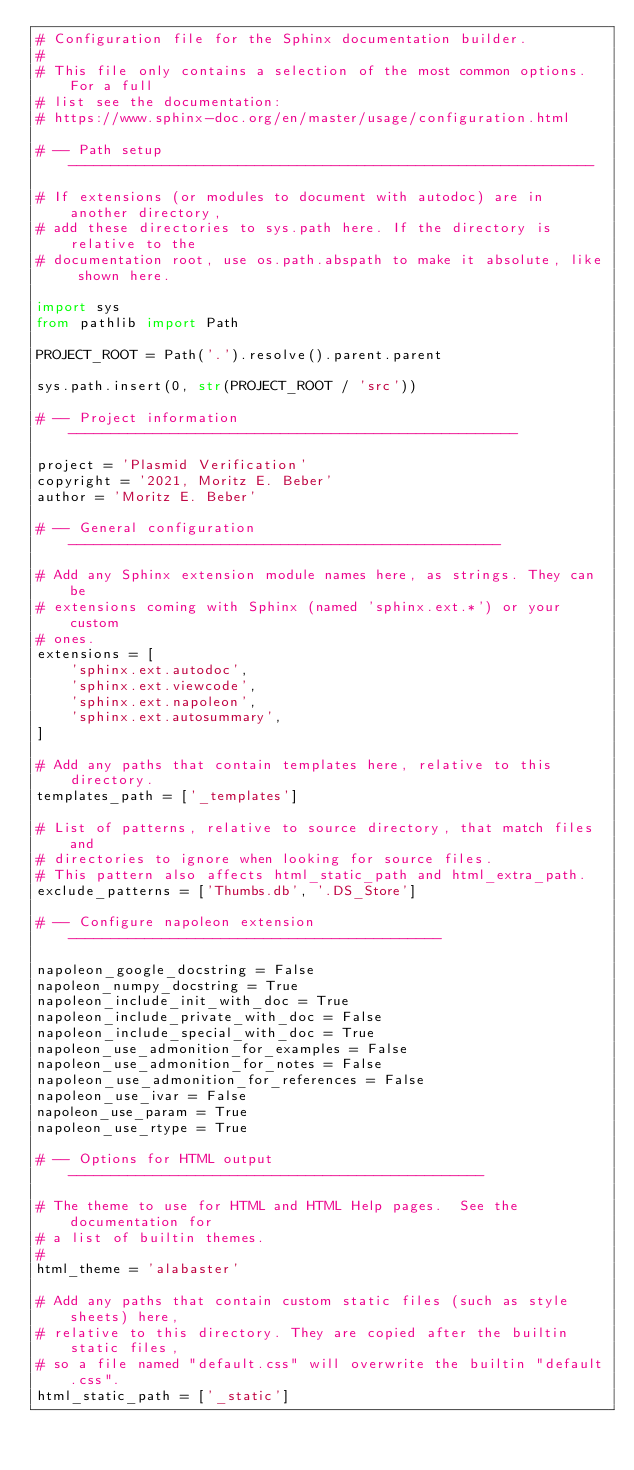Convert code to text. <code><loc_0><loc_0><loc_500><loc_500><_Python_># Configuration file for the Sphinx documentation builder.
#
# This file only contains a selection of the most common options. For a full
# list see the documentation:
# https://www.sphinx-doc.org/en/master/usage/configuration.html

# -- Path setup --------------------------------------------------------------

# If extensions (or modules to document with autodoc) are in another directory,
# add these directories to sys.path here. If the directory is relative to the
# documentation root, use os.path.abspath to make it absolute, like shown here.

import sys
from pathlib import Path

PROJECT_ROOT = Path('.').resolve().parent.parent

sys.path.insert(0, str(PROJECT_ROOT / 'src'))

# -- Project information -----------------------------------------------------

project = 'Plasmid Verification'
copyright = '2021, Moritz E. Beber'
author = 'Moritz E. Beber'

# -- General configuration ---------------------------------------------------

# Add any Sphinx extension module names here, as strings. They can be
# extensions coming with Sphinx (named 'sphinx.ext.*') or your custom
# ones.
extensions = [
    'sphinx.ext.autodoc',
    'sphinx.ext.viewcode',
    'sphinx.ext.napoleon',
    'sphinx.ext.autosummary',
]

# Add any paths that contain templates here, relative to this directory.
templates_path = ['_templates']

# List of patterns, relative to source directory, that match files and
# directories to ignore when looking for source files.
# This pattern also affects html_static_path and html_extra_path.
exclude_patterns = ['Thumbs.db', '.DS_Store']

# -- Configure napoleon extension --------------------------------------------

napoleon_google_docstring = False
napoleon_numpy_docstring = True
napoleon_include_init_with_doc = True
napoleon_include_private_with_doc = False
napoleon_include_special_with_doc = True
napoleon_use_admonition_for_examples = False
napoleon_use_admonition_for_notes = False
napoleon_use_admonition_for_references = False
napoleon_use_ivar = False
napoleon_use_param = True
napoleon_use_rtype = True

# -- Options for HTML output -------------------------------------------------

# The theme to use for HTML and HTML Help pages.  See the documentation for
# a list of builtin themes.
#
html_theme = 'alabaster'

# Add any paths that contain custom static files (such as style sheets) here,
# relative to this directory. They are copied after the builtin static files,
# so a file named "default.css" will overwrite the builtin "default.css".
html_static_path = ['_static']
</code> 